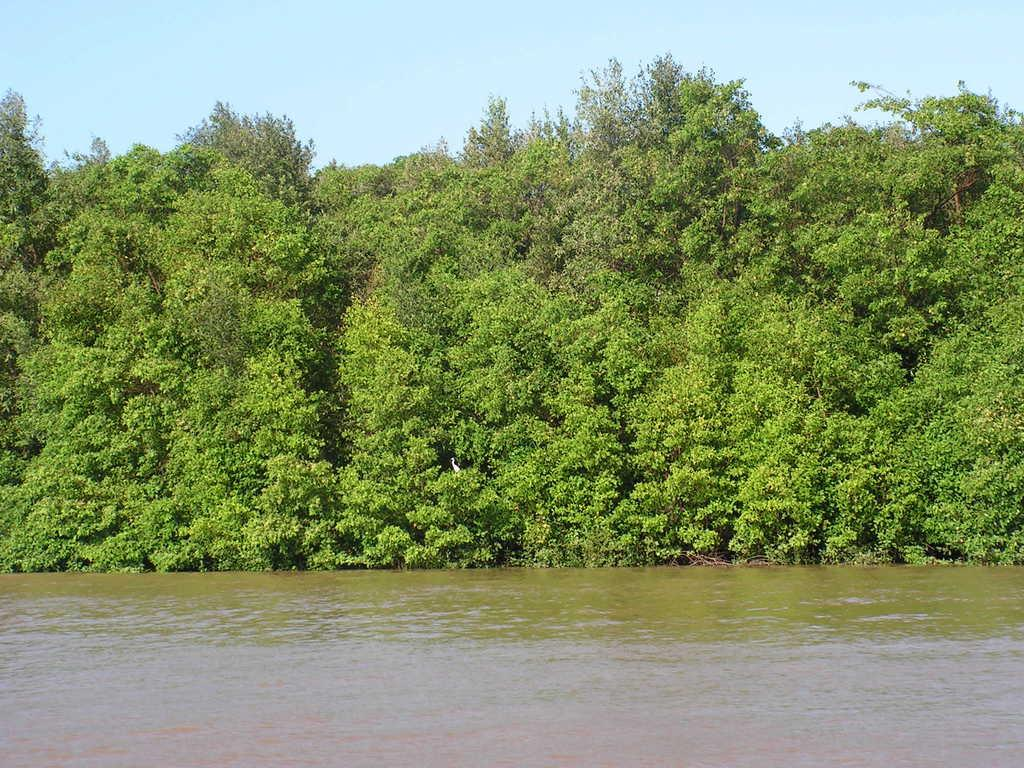What is present in the picture? There is water and trees in the picture. What can be seen in the background of the picture? The sky is visible in the background of the picture. What type of meal is being prepared in the picture? There is no meal being prepared in the picture; it features water, trees, and the sky. How many cars can be seen driving on the trail in the picture? There is no trail or cars present in the picture; it only contains water, trees, and the sky. 